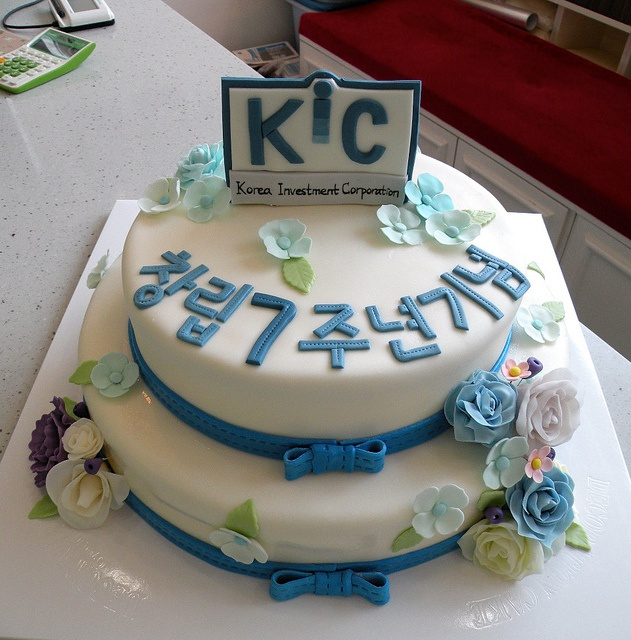Describe the objects in this image and their specific colors. I can see a cake in darkgray, lightgray, and gray tones in this image. 